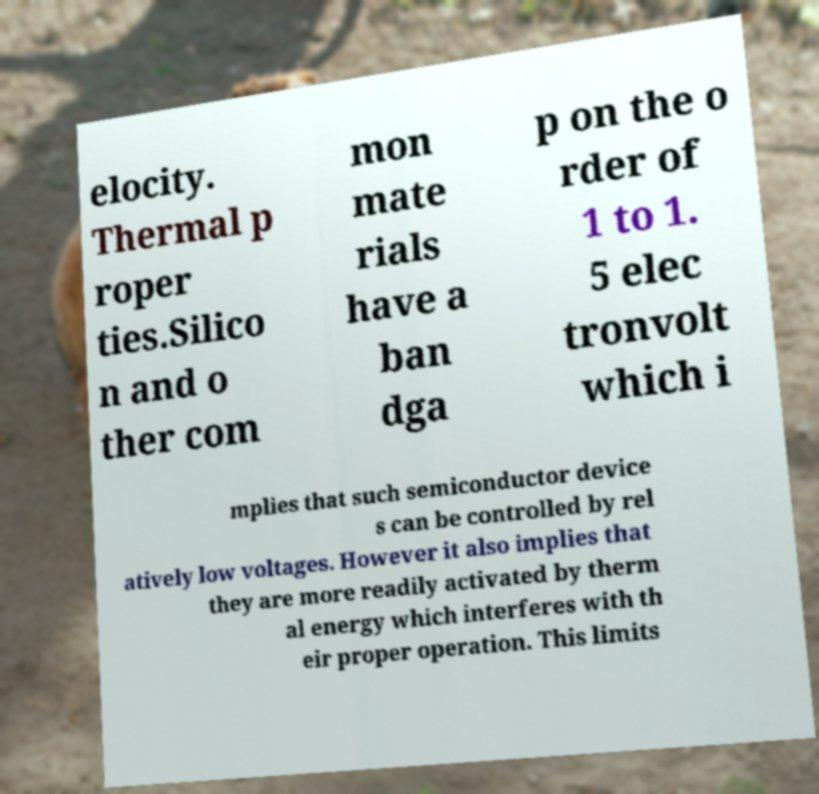Could you assist in decoding the text presented in this image and type it out clearly? elocity. Thermal p roper ties.Silico n and o ther com mon mate rials have a ban dga p on the o rder of 1 to 1. 5 elec tronvolt which i mplies that such semiconductor device s can be controlled by rel atively low voltages. However it also implies that they are more readily activated by therm al energy which interferes with th eir proper operation. This limits 